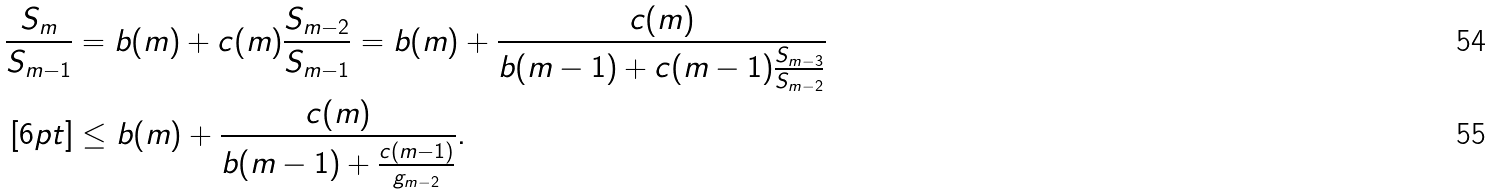Convert formula to latex. <formula><loc_0><loc_0><loc_500><loc_500>\frac { S _ { m } } { S _ { m - 1 } } & = b ( m ) + c ( m ) \frac { S _ { m - 2 } } { S _ { m - 1 } } = b ( m ) + \frac { c ( m ) } { b ( m - 1 ) + c ( m - 1 ) \frac { S _ { m - 3 } } { S _ { m - 2 } } } \\ [ 6 p t ] & \leq b ( m ) + \frac { c ( m ) } { b ( m - 1 ) + \frac { c ( m - 1 ) } { g _ { m - 2 } } } .</formula> 